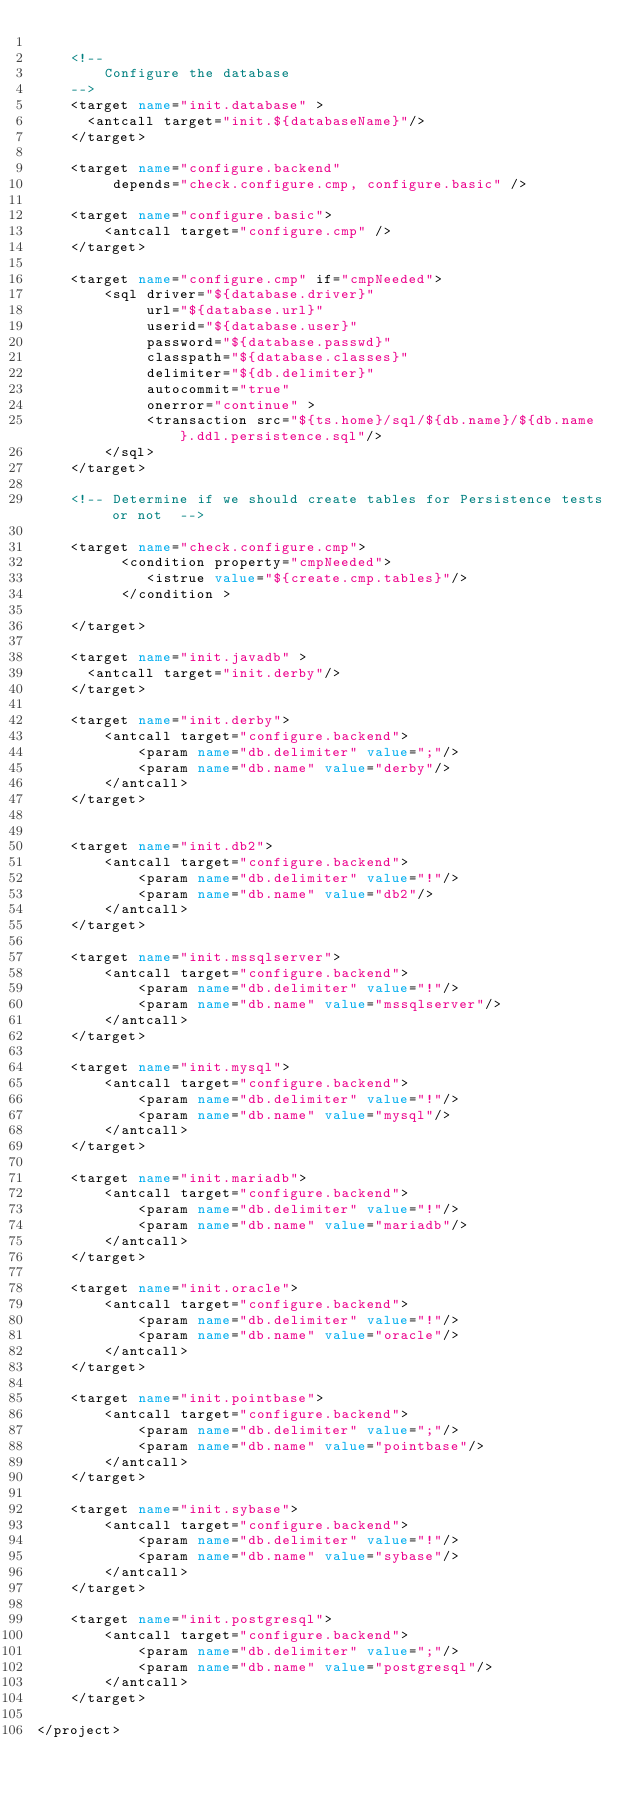Convert code to text. <code><loc_0><loc_0><loc_500><loc_500><_XML_>
    <!--
        Configure the database
    -->
    <target name="init.database" >
      <antcall target="init.${databaseName}"/>
    </target>

    <target name="configure.backend" 
         depends="check.configure.cmp, configure.basic" />

    <target name="configure.basic">
        <antcall target="configure.cmp" />
    </target>

    <target name="configure.cmp" if="cmpNeeded">
        <sql driver="${database.driver}"
             url="${database.url}"
             userid="${database.user}"
             password="${database.passwd}"
             classpath="${database.classes}"
             delimiter="${db.delimiter}"
             autocommit="true"
             onerror="continue" >
             <transaction src="${ts.home}/sql/${db.name}/${db.name}.ddl.persistence.sql"/>
        </sql>
    </target>

    <!-- Determine if we should create tables for Persistence tests or not  -->

    <target name="check.configure.cmp">
          <condition property="cmpNeeded">
             <istrue value="${create.cmp.tables}"/>
          </condition >

    </target>

    <target name="init.javadb" >
      <antcall target="init.derby"/>
    </target>

    <target name="init.derby">
        <antcall target="configure.backend">
            <param name="db.delimiter" value=";"/>
            <param name="db.name" value="derby"/>
        </antcall>
    </target>


    <target name="init.db2">
        <antcall target="configure.backend">
            <param name="db.delimiter" value="!"/>
            <param name="db.name" value="db2"/>
        </antcall>
    </target>

    <target name="init.mssqlserver">
        <antcall target="configure.backend">
            <param name="db.delimiter" value="!"/>
            <param name="db.name" value="mssqlserver"/>
        </antcall>
    </target>

    <target name="init.mysql">
        <antcall target="configure.backend">
            <param name="db.delimiter" value="!"/>
            <param name="db.name" value="mysql"/>
        </antcall>
    </target>

    <target name="init.mariadb">
        <antcall target="configure.backend">
            <param name="db.delimiter" value="!"/>
            <param name="db.name" value="mariadb"/>
        </antcall>
    </target>

    <target name="init.oracle">
        <antcall target="configure.backend">
            <param name="db.delimiter" value="!"/>
            <param name="db.name" value="oracle"/>
        </antcall>
    </target>

    <target name="init.pointbase">
        <antcall target="configure.backend">
            <param name="db.delimiter" value=";"/>
            <param name="db.name" value="pointbase"/>
        </antcall>
    </target>

    <target name="init.sybase">
        <antcall target="configure.backend">
            <param name="db.delimiter" value="!"/>
            <param name="db.name" value="sybase"/>
        </antcall>
    </target>

    <target name="init.postgresql">
        <antcall target="configure.backend">
            <param name="db.delimiter" value=";"/>
            <param name="db.name" value="postgresql"/>
        </antcall>
    </target>

</project>
</code> 